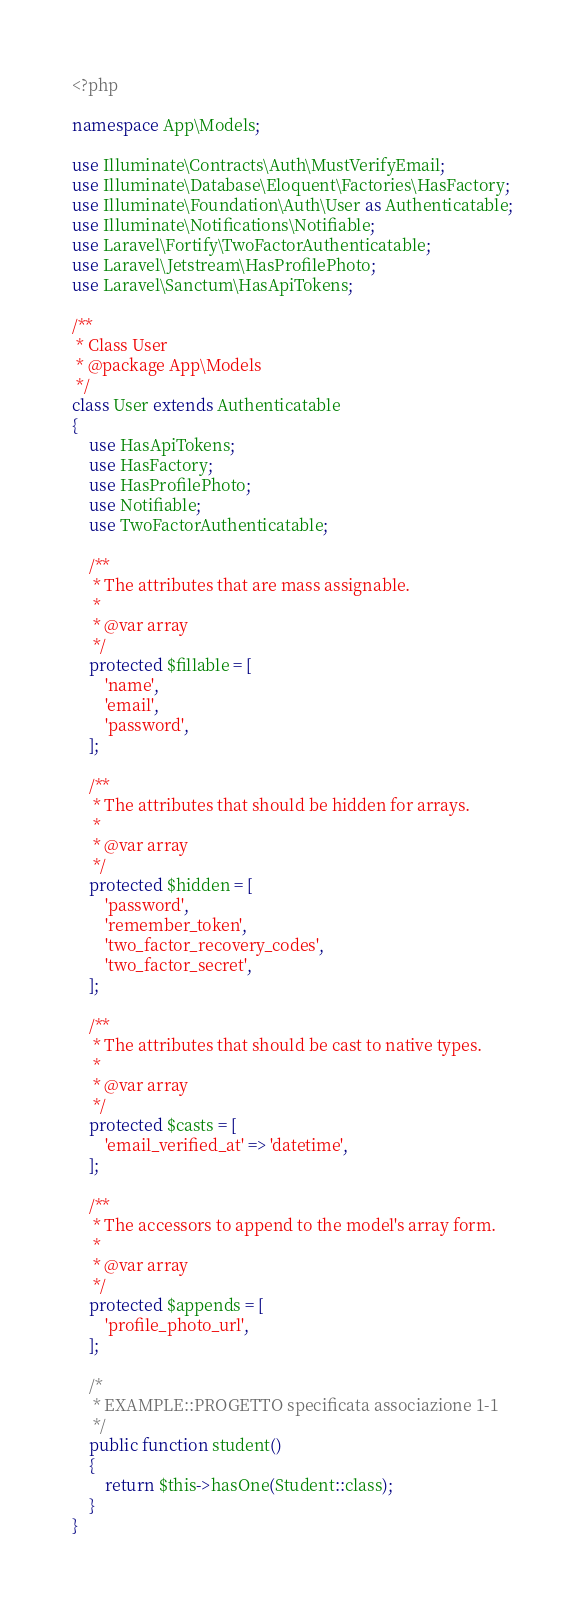Convert code to text. <code><loc_0><loc_0><loc_500><loc_500><_PHP_><?php

namespace App\Models;

use Illuminate\Contracts\Auth\MustVerifyEmail;
use Illuminate\Database\Eloquent\Factories\HasFactory;
use Illuminate\Foundation\Auth\User as Authenticatable;
use Illuminate\Notifications\Notifiable;
use Laravel\Fortify\TwoFactorAuthenticatable;
use Laravel\Jetstream\HasProfilePhoto;
use Laravel\Sanctum\HasApiTokens;

/**
 * Class User
 * @package App\Models
 */
class User extends Authenticatable
{
    use HasApiTokens;
    use HasFactory;
    use HasProfilePhoto;
    use Notifiable;
    use TwoFactorAuthenticatable;

    /**
     * The attributes that are mass assignable.
     *
     * @var array
     */
    protected $fillable = [
        'name',
        'email',
        'password',
    ];

    /**
     * The attributes that should be hidden for arrays.
     *
     * @var array
     */
    protected $hidden = [
        'password',
        'remember_token',
        'two_factor_recovery_codes',
        'two_factor_secret',
    ];

    /**
     * The attributes that should be cast to native types.
     *
     * @var array
     */
    protected $casts = [
        'email_verified_at' => 'datetime',
    ];

    /**
     * The accessors to append to the model's array form.
     *
     * @var array
     */
    protected $appends = [
        'profile_photo_url',
    ];

    /*
     * EXAMPLE::PROGETTO specificata associazione 1-1
     */
    public function student()
    {
        return $this->hasOne(Student::class);
    }
}
</code> 